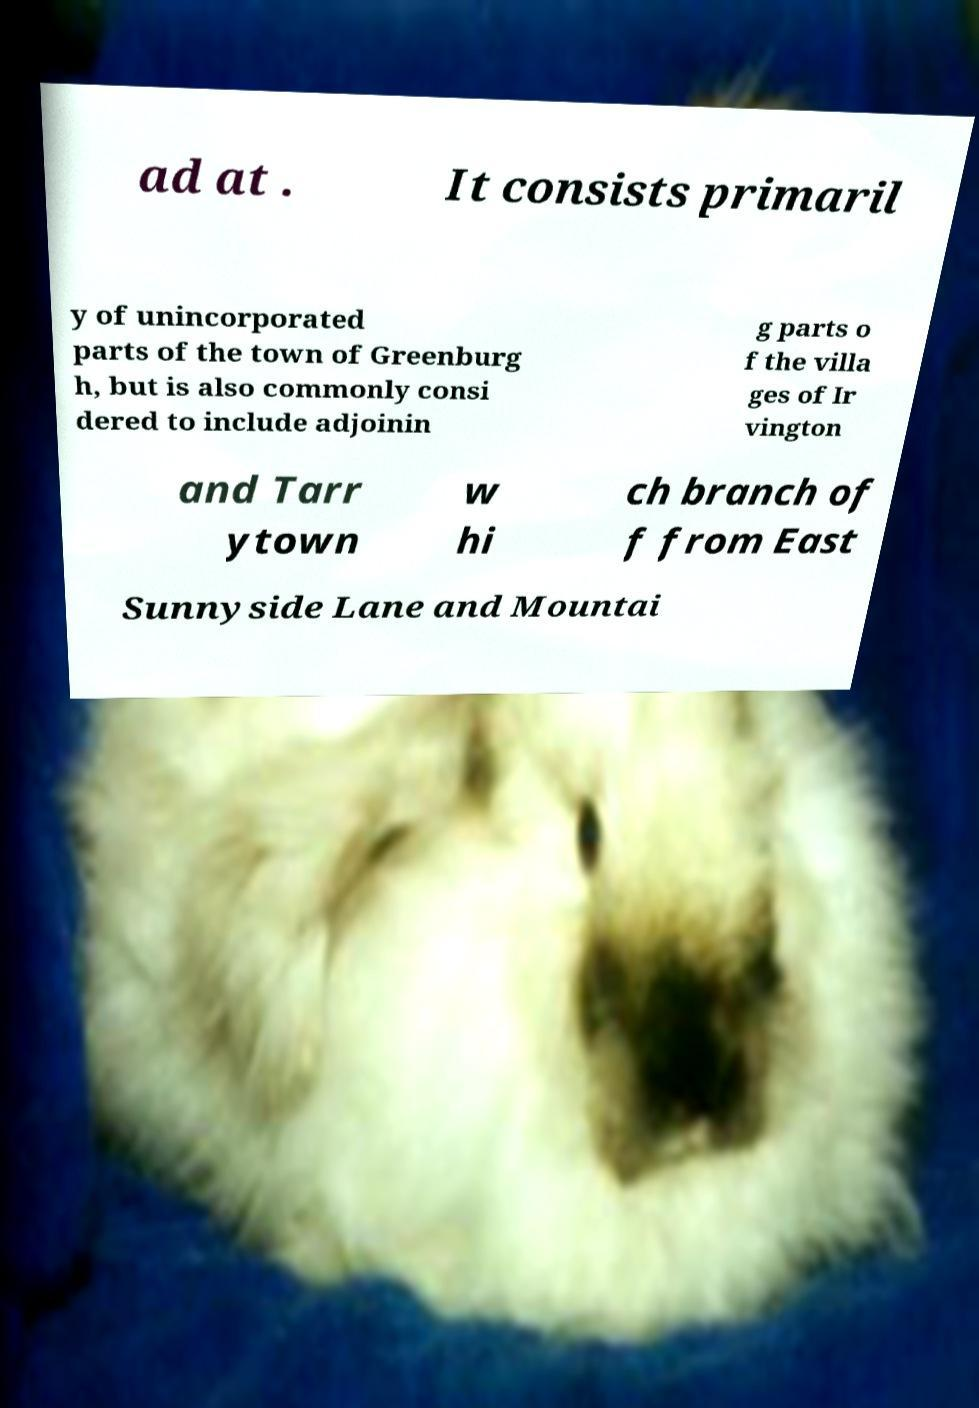Can you read and provide the text displayed in the image?This photo seems to have some interesting text. Can you extract and type it out for me? ad at . It consists primaril y of unincorporated parts of the town of Greenburg h, but is also commonly consi dered to include adjoinin g parts o f the villa ges of Ir vington and Tarr ytown w hi ch branch of f from East Sunnyside Lane and Mountai 